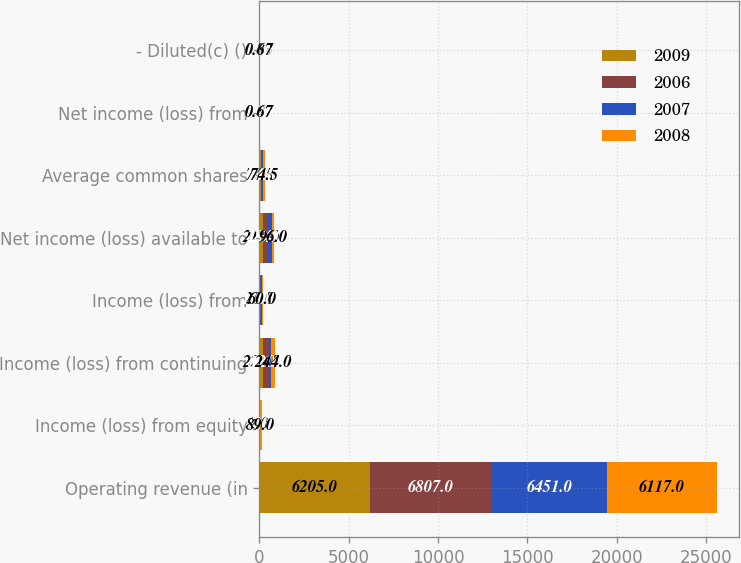Convert chart. <chart><loc_0><loc_0><loc_500><loc_500><stacked_bar_chart><ecel><fcel>Operating revenue (in<fcel>Income (loss) from equity<fcel>Income (loss) from continuing<fcel>Income (loss) from<fcel>Net income (loss) available to<fcel>Average common shares<fcel>Net income (loss) from<fcel>- Diluted(c) ()<nl><fcel>2009<fcel>6205<fcel>2<fcel>220<fcel>20<fcel>218<fcel>74.5<fcel>0.87<fcel>0.83<nl><fcel>2006<fcel>6807<fcel>5<fcel>301<fcel>1<fcel>284<fcel>74.5<fcel>1.25<fcel>1.2<nl><fcel>2007<fcel>6451<fcel>40<fcel>120<fcel>110<fcel>234<fcel>74.5<fcel>0.65<fcel>0.65<nl><fcel>2008<fcel>6117<fcel>89<fcel>244<fcel>60<fcel>96<fcel>74.5<fcel>0.67<fcel>0.67<nl></chart> 